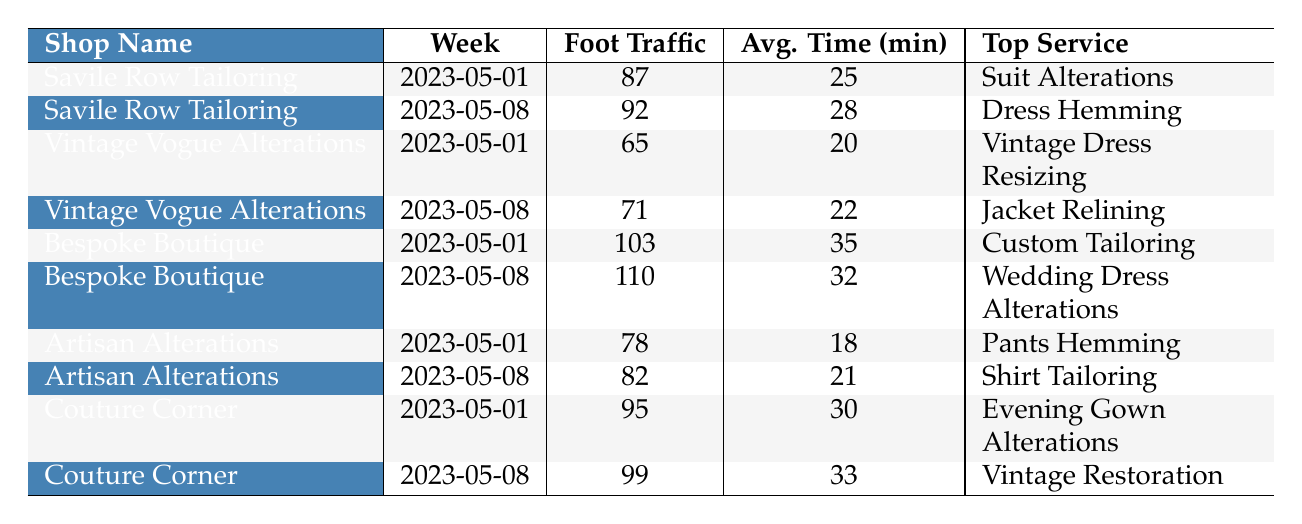What was the foot traffic for Bespoke Boutique in the week of May 8, 2023? According to the table, the foot traffic for Bespoke Boutique in the week of May 8, 2023, is listed as 110.
Answer: 110 Which shop had the highest average time spent by customers during the first week of May 2023? The table shows that Bespoke Boutique had the highest average time spent at 35 minutes in the week of May 1, 2023.
Answer: Bespoke Boutique What is the total foot traffic for Artisan Alterations over both weeks? To find this, we add the foot traffic for Artisan Alterations in both weeks: 78 (May 1) + 82 (May 8) = 160.
Answer: 160 Did Vintage Vogue Alterations see an increase in foot traffic from the first week to the second week? By comparing the foot traffic, Vintage Vogue Alterations had 65 in the first week and 71 in the second week, which is an increase.
Answer: Yes Which shop provided the top service of "Dress Hemming" during the second week of May? The table lists Savile Row Tailoring as the shop providing the top service of "Dress Hemming" in the week of May 8, 2023.
Answer: Savile Row Tailoring What was the average foot traffic for Couture Corner across both weeks? To calculate the average foot traffic for Couture Corner, we sum the foot traffic for both weeks (95 + 99 = 194) and divide by 2, resulting in 97.
Answer: 97 Which shop had the lowest foot traffic on May 1, 2023? The table indicates that Vintage Vogue Alterations had the lowest foot traffic on May 1, 2023, with 65.
Answer: Vintage Vogue Alterations What is the difference in foot traffic for Savile Row Tailoring between the two weeks? The difference in foot traffic for Savile Row Tailoring is calculated by subtracting the foot traffic of May 1 (87) from that of May 8 (92), resulting in 5.
Answer: 5 Which service was the top service for Artisan Alterations in both weeks? The top service for Artisan Alterations was "Pants Hemming" in the first week and "Shirt Tailoring" in the second week, indicating they changed their top service.
Answer: No, it changed How much time did customers spend on average at Bespoke Boutique during the two weeks? To find the average time, we add the time spent across both weeks (35 + 32 = 67) and divide by 2, resulting in 33.5 minutes.
Answer: 33.5 